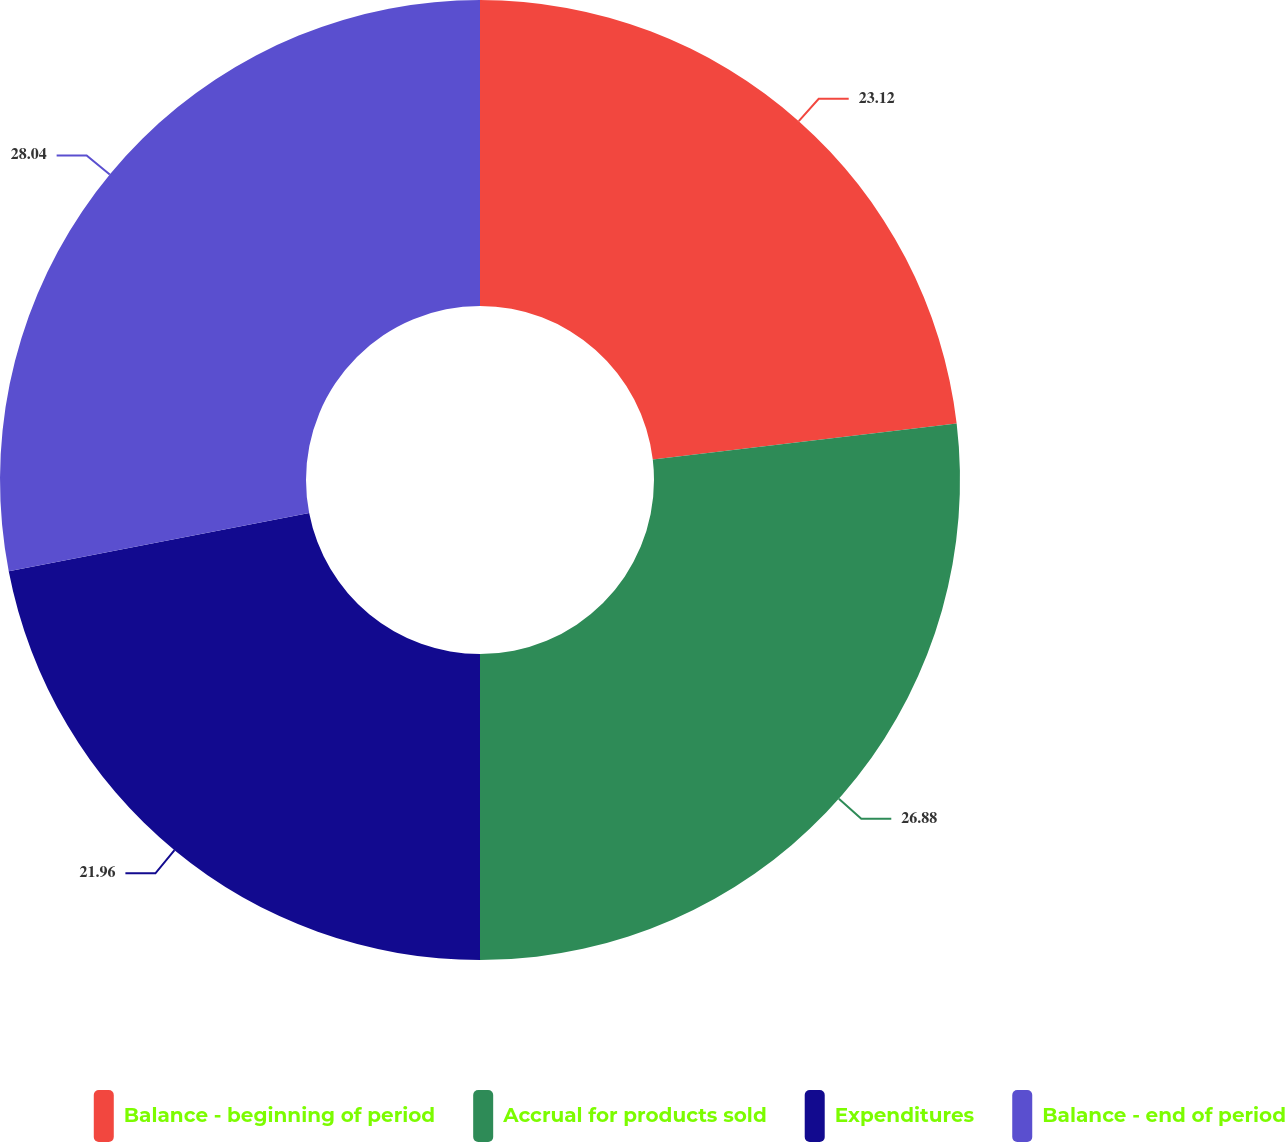Convert chart to OTSL. <chart><loc_0><loc_0><loc_500><loc_500><pie_chart><fcel>Balance - beginning of period<fcel>Accrual for products sold<fcel>Expenditures<fcel>Balance - end of period<nl><fcel>23.12%<fcel>26.88%<fcel>21.96%<fcel>28.04%<nl></chart> 